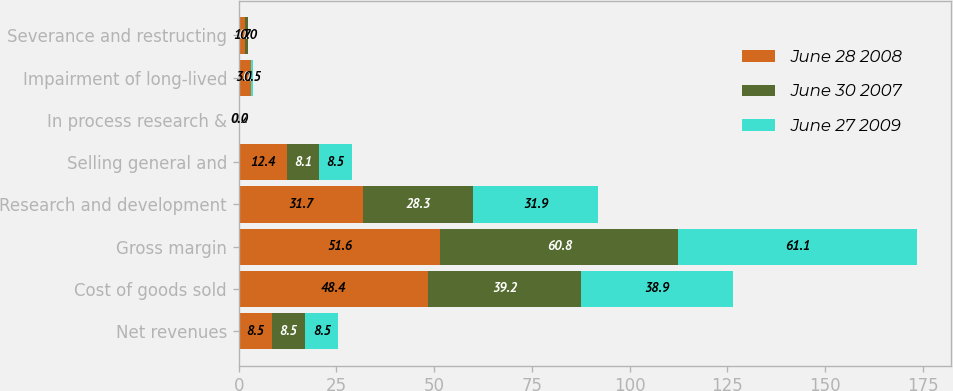Convert chart. <chart><loc_0><loc_0><loc_500><loc_500><stacked_bar_chart><ecel><fcel>Net revenues<fcel>Cost of goods sold<fcel>Gross margin<fcel>Research and development<fcel>Selling general and<fcel>In process research &<fcel>Impairment of long-lived<fcel>Severance and restructing<nl><fcel>June 28 2008<fcel>8.5<fcel>48.4<fcel>51.6<fcel>31.7<fcel>12.4<fcel>0.2<fcel>3.1<fcel>1.7<nl><fcel>June 30 2007<fcel>8.5<fcel>39.2<fcel>60.8<fcel>28.3<fcel>8.1<fcel>0<fcel>0<fcel>0.7<nl><fcel>June 27 2009<fcel>8.5<fcel>38.9<fcel>61.1<fcel>31.9<fcel>8.5<fcel>0<fcel>0.5<fcel>0<nl></chart> 